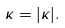Convert formula to latex. <formula><loc_0><loc_0><loc_500><loc_500>\kappa = | { \kappa } | .</formula> 